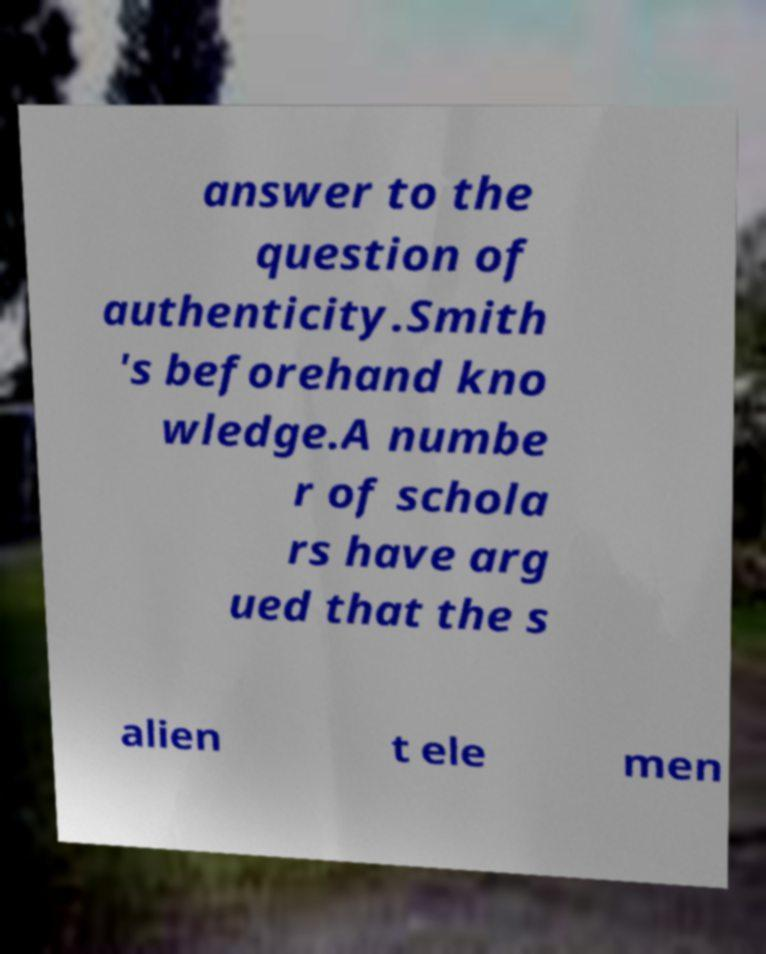Could you extract and type out the text from this image? answer to the question of authenticity.Smith 's beforehand kno wledge.A numbe r of schola rs have arg ued that the s alien t ele men 